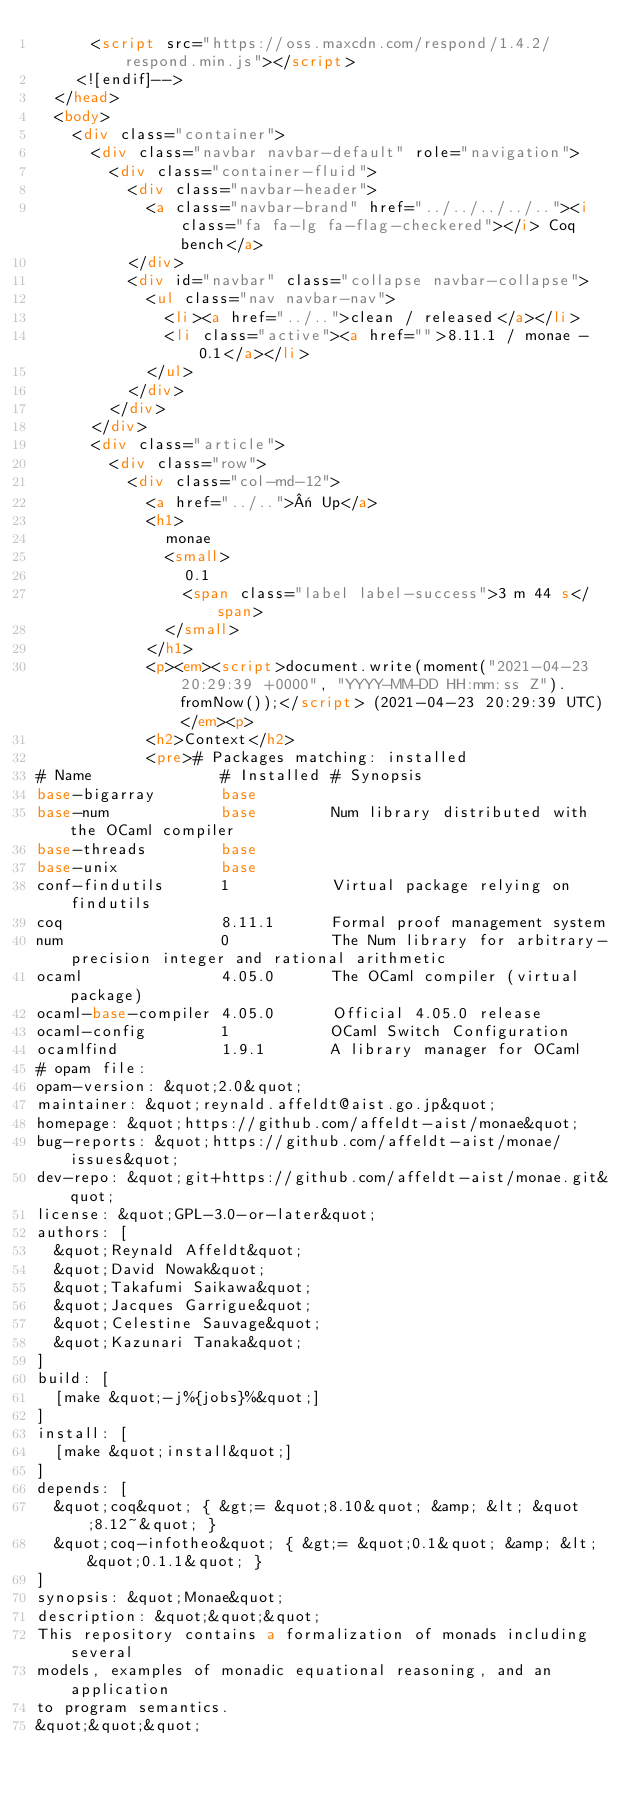Convert code to text. <code><loc_0><loc_0><loc_500><loc_500><_HTML_>      <script src="https://oss.maxcdn.com/respond/1.4.2/respond.min.js"></script>
    <![endif]-->
  </head>
  <body>
    <div class="container">
      <div class="navbar navbar-default" role="navigation">
        <div class="container-fluid">
          <div class="navbar-header">
            <a class="navbar-brand" href="../../../../.."><i class="fa fa-lg fa-flag-checkered"></i> Coq bench</a>
          </div>
          <div id="navbar" class="collapse navbar-collapse">
            <ul class="nav navbar-nav">
              <li><a href="../..">clean / released</a></li>
              <li class="active"><a href="">8.11.1 / monae - 0.1</a></li>
            </ul>
          </div>
        </div>
      </div>
      <div class="article">
        <div class="row">
          <div class="col-md-12">
            <a href="../..">« Up</a>
            <h1>
              monae
              <small>
                0.1
                <span class="label label-success">3 m 44 s</span>
              </small>
            </h1>
            <p><em><script>document.write(moment("2021-04-23 20:29:39 +0000", "YYYY-MM-DD HH:mm:ss Z").fromNow());</script> (2021-04-23 20:29:39 UTC)</em><p>
            <h2>Context</h2>
            <pre># Packages matching: installed
# Name              # Installed # Synopsis
base-bigarray       base
base-num            base        Num library distributed with the OCaml compiler
base-threads        base
base-unix           base
conf-findutils      1           Virtual package relying on findutils
coq                 8.11.1      Formal proof management system
num                 0           The Num library for arbitrary-precision integer and rational arithmetic
ocaml               4.05.0      The OCaml compiler (virtual package)
ocaml-base-compiler 4.05.0      Official 4.05.0 release
ocaml-config        1           OCaml Switch Configuration
ocamlfind           1.9.1       A library manager for OCaml
# opam file:
opam-version: &quot;2.0&quot;
maintainer: &quot;reynald.affeldt@aist.go.jp&quot;
homepage: &quot;https://github.com/affeldt-aist/monae&quot;
bug-reports: &quot;https://github.com/affeldt-aist/monae/issues&quot;
dev-repo: &quot;git+https://github.com/affeldt-aist/monae.git&quot;
license: &quot;GPL-3.0-or-later&quot;
authors: [
  &quot;Reynald Affeldt&quot;
  &quot;David Nowak&quot;
  &quot;Takafumi Saikawa&quot;
  &quot;Jacques Garrigue&quot;
  &quot;Celestine Sauvage&quot;
  &quot;Kazunari Tanaka&quot;
]
build: [
  [make &quot;-j%{jobs}%&quot;]
]
install: [
  [make &quot;install&quot;]
]
depends: [
  &quot;coq&quot; { &gt;= &quot;8.10&quot; &amp; &lt; &quot;8.12~&quot; }
  &quot;coq-infotheo&quot; { &gt;= &quot;0.1&quot; &amp; &lt; &quot;0.1.1&quot; }
]
synopsis: &quot;Monae&quot;
description: &quot;&quot;&quot;
This repository contains a formalization of monads including several
models, examples of monadic equational reasoning, and an application
to program semantics.
&quot;&quot;&quot;</code> 